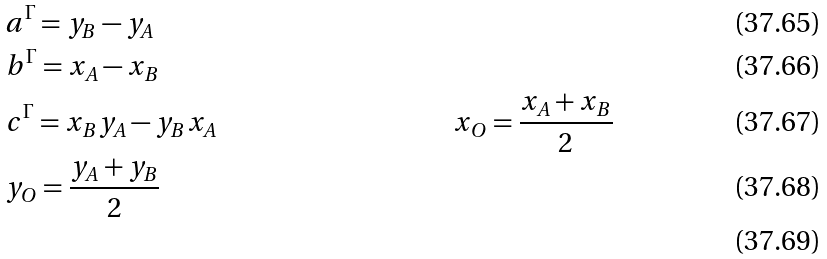Convert formula to latex. <formula><loc_0><loc_0><loc_500><loc_500>& a ^ { \Gamma } = y _ { B } - y _ { A } \\ & b ^ { \Gamma } = x _ { A } - x _ { B } \\ & c ^ { \Gamma } = x _ { B } y _ { A } - y _ { B } x _ { A } \quad & x _ { O } = \frac { x _ { A } + x _ { B } } { 2 } \\ & y _ { O } = \frac { y _ { A } + y _ { B } } { 2 } \\</formula> 